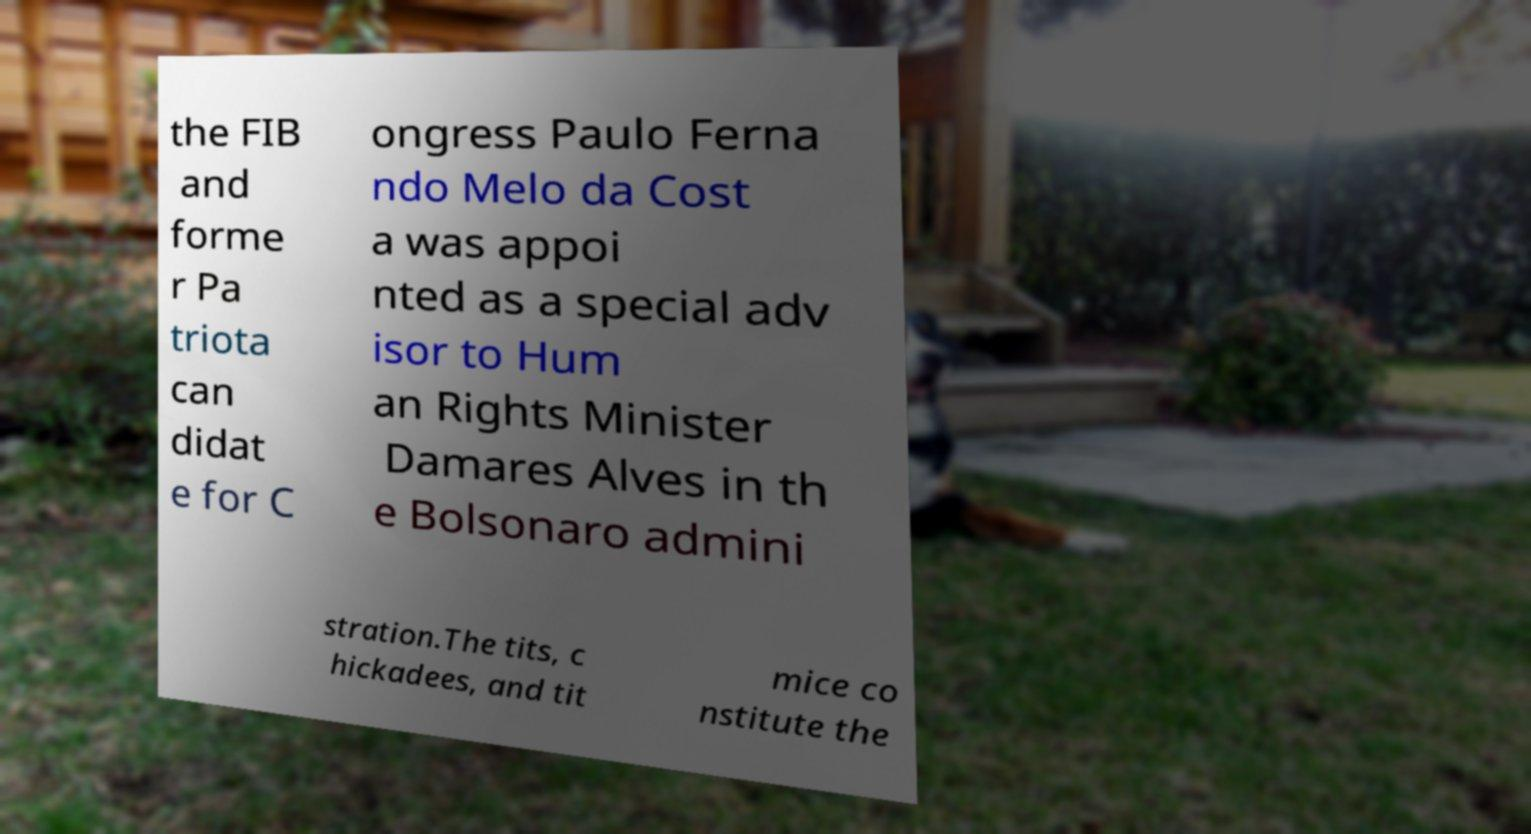For documentation purposes, I need the text within this image transcribed. Could you provide that? the FIB and forme r Pa triota can didat e for C ongress Paulo Ferna ndo Melo da Cost a was appoi nted as a special adv isor to Hum an Rights Minister Damares Alves in th e Bolsonaro admini stration.The tits, c hickadees, and tit mice co nstitute the 